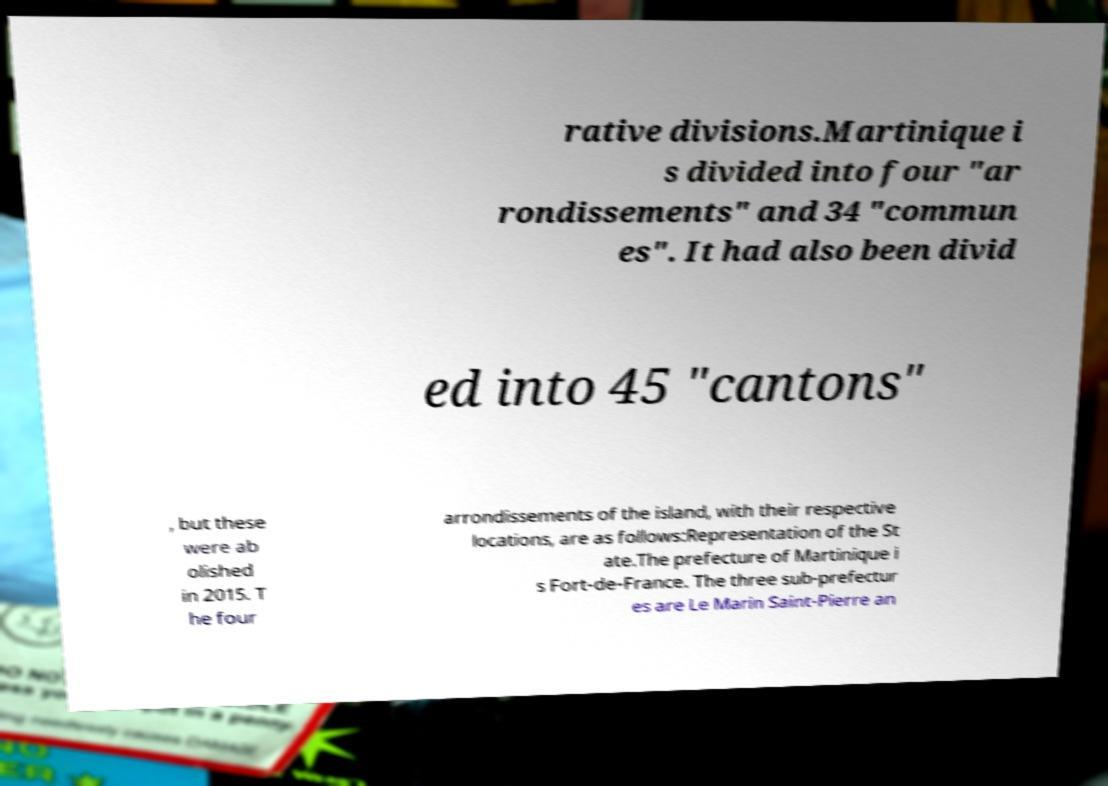Could you extract and type out the text from this image? rative divisions.Martinique i s divided into four "ar rondissements" and 34 "commun es". It had also been divid ed into 45 "cantons" , but these were ab olished in 2015. T he four arrondissements of the island, with their respective locations, are as follows:Representation of the St ate.The prefecture of Martinique i s Fort-de-France. The three sub-prefectur es are Le Marin Saint-Pierre an 